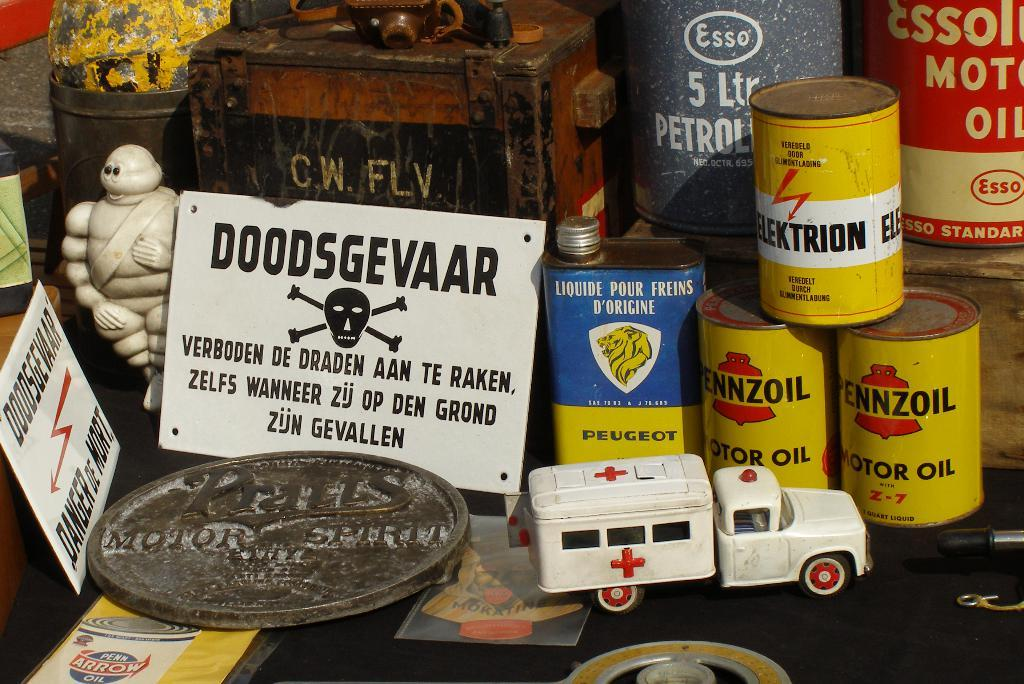<image>
Render a clear and concise summary of the photo. A sign on a foreign language looks foreboding in amongst oil cans, petrol cans and a model ambulance. 